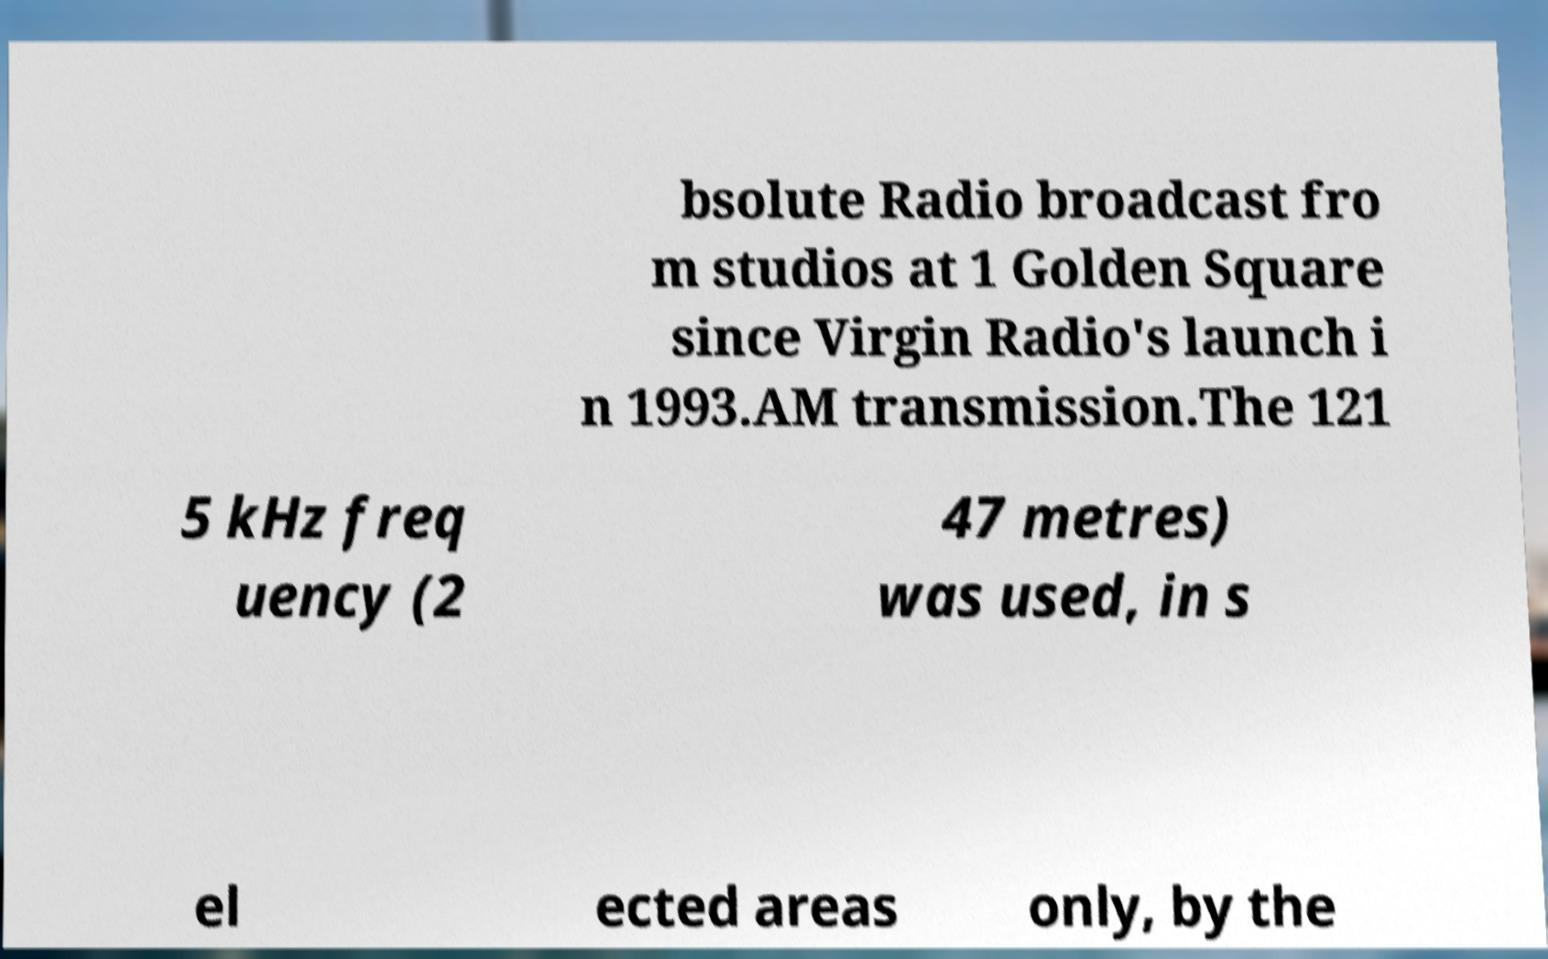Please read and relay the text visible in this image. What does it say? bsolute Radio broadcast fro m studios at 1 Golden Square since Virgin Radio's launch i n 1993.AM transmission.The 121 5 kHz freq uency (2 47 metres) was used, in s el ected areas only, by the 